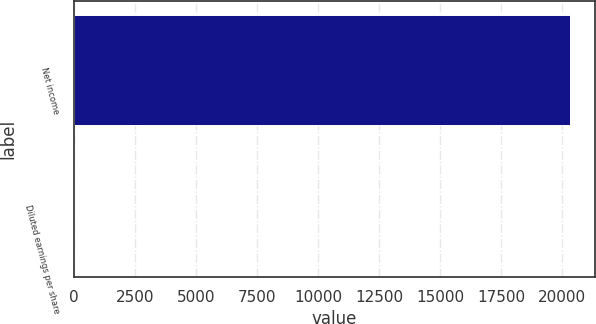Convert chart to OTSL. <chart><loc_0><loc_0><loc_500><loc_500><bar_chart><fcel>Net income<fcel>Diluted earnings per share<nl><fcel>20328<fcel>0.43<nl></chart> 